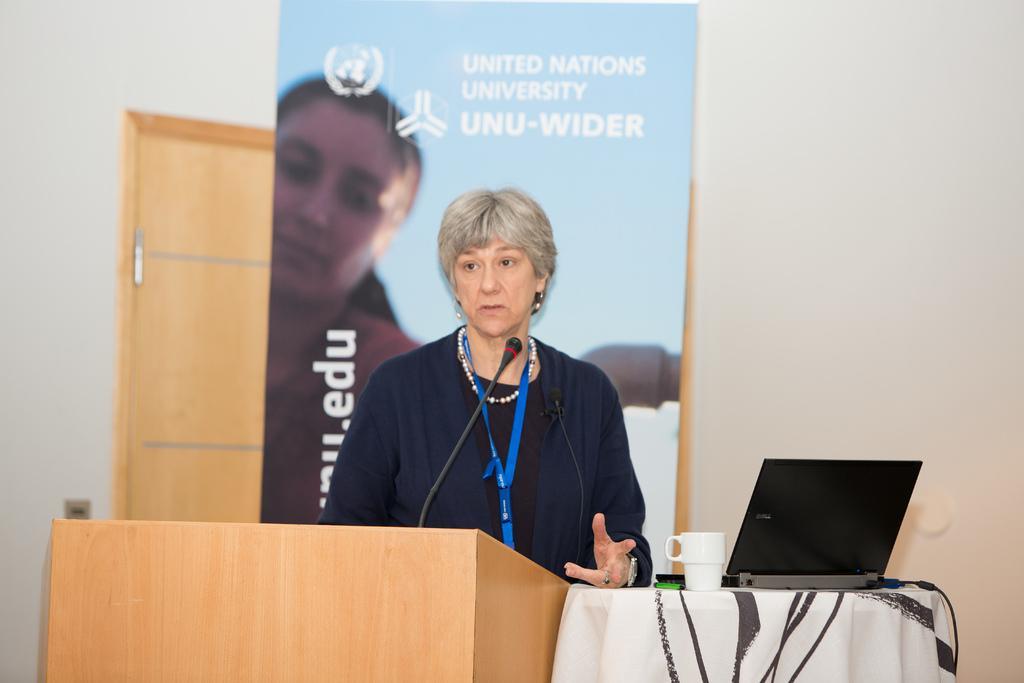Please provide a concise description of this image. In this image I can see a woman, a podium, a mug, a laptop, a banner in background, a mic and on this banner I can see something is written. I can also see white colour table cloth over here. 